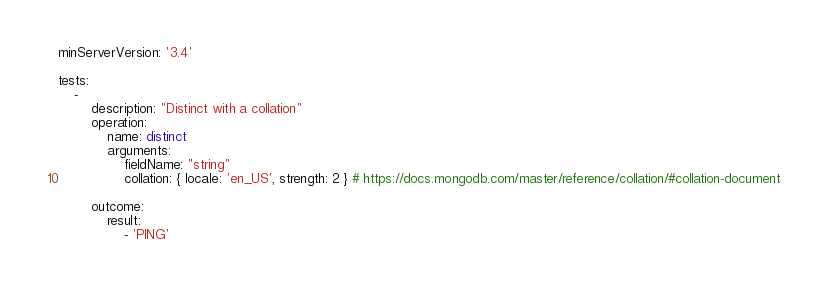<code> <loc_0><loc_0><loc_500><loc_500><_YAML_>minServerVersion: '3.4'

tests:
    -
        description: "Distinct with a collation"
        operation:
            name: distinct
            arguments:
                fieldName: "string"
                collation: { locale: 'en_US', strength: 2 } # https://docs.mongodb.com/master/reference/collation/#collation-document

        outcome:
            result:
                - 'PING'
</code> 